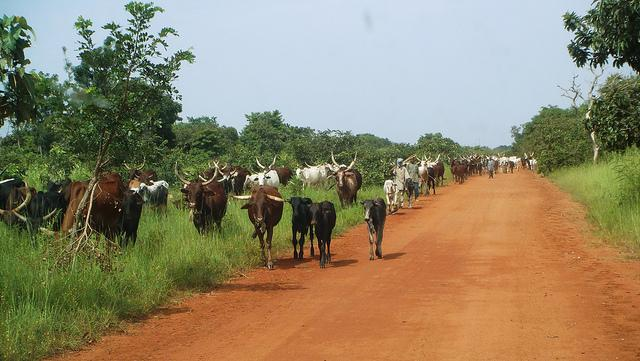What do many of these animals have? Please explain your reasoning. horns. The male species of this animal has horns. 